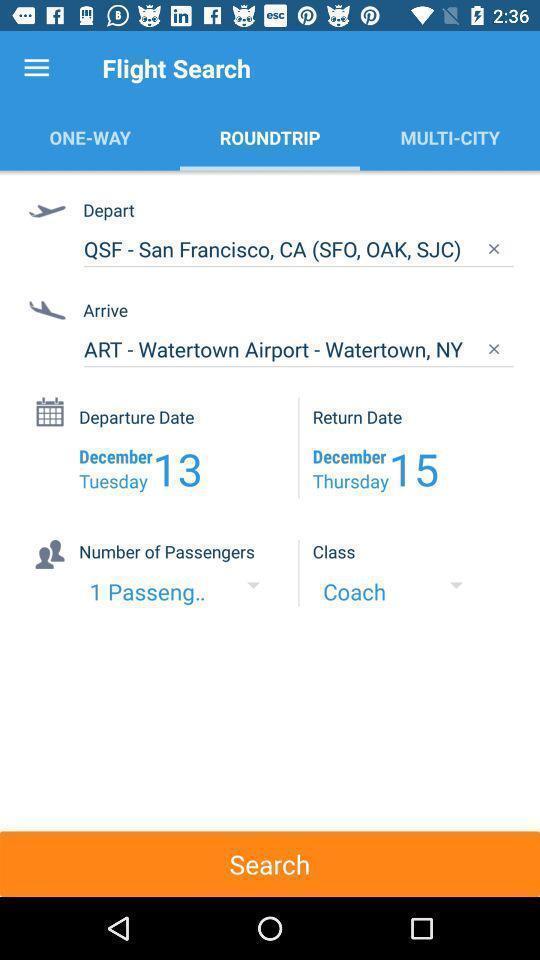Explain what's happening in this screen capture. Screen shows roundtrip search page in travel app. 